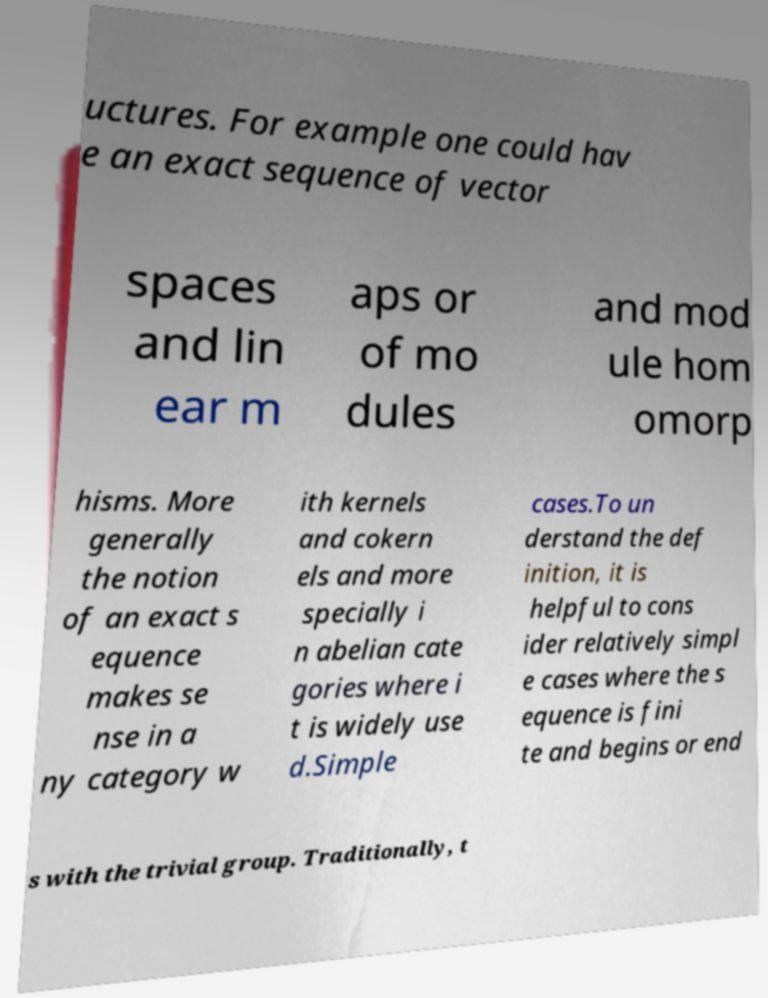I need the written content from this picture converted into text. Can you do that? uctures. For example one could hav e an exact sequence of vector spaces and lin ear m aps or of mo dules and mod ule hom omorp hisms. More generally the notion of an exact s equence makes se nse in a ny category w ith kernels and cokern els and more specially i n abelian cate gories where i t is widely use d.Simple cases.To un derstand the def inition, it is helpful to cons ider relatively simpl e cases where the s equence is fini te and begins or end s with the trivial group. Traditionally, t 